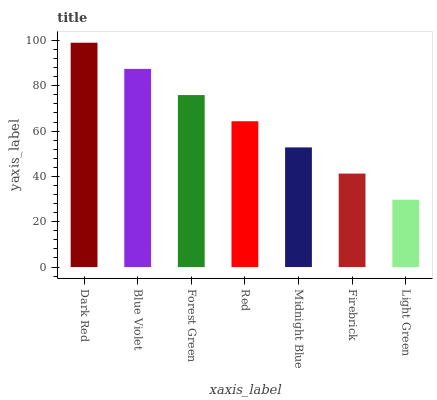Is Light Green the minimum?
Answer yes or no. Yes. Is Dark Red the maximum?
Answer yes or no. Yes. Is Blue Violet the minimum?
Answer yes or no. No. Is Blue Violet the maximum?
Answer yes or no. No. Is Dark Red greater than Blue Violet?
Answer yes or no. Yes. Is Blue Violet less than Dark Red?
Answer yes or no. Yes. Is Blue Violet greater than Dark Red?
Answer yes or no. No. Is Dark Red less than Blue Violet?
Answer yes or no. No. Is Red the high median?
Answer yes or no. Yes. Is Red the low median?
Answer yes or no. Yes. Is Midnight Blue the high median?
Answer yes or no. No. Is Dark Red the low median?
Answer yes or no. No. 